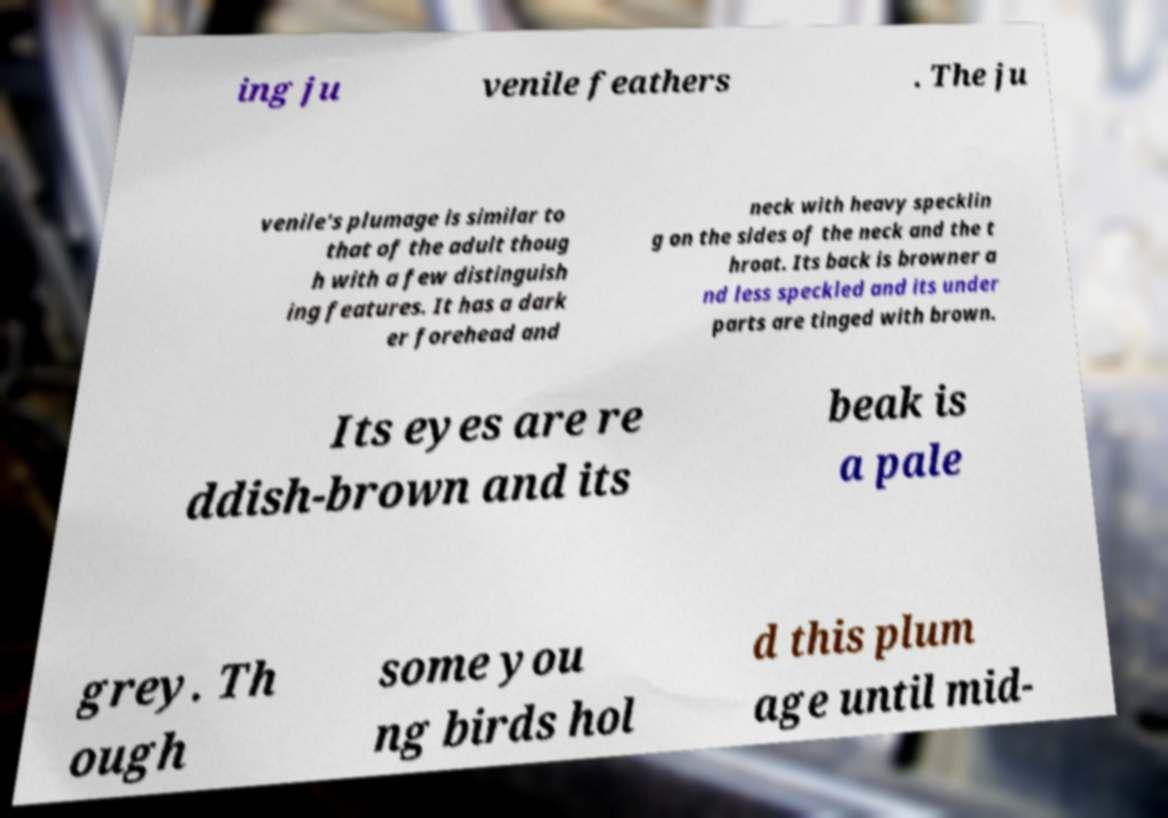Please read and relay the text visible in this image. What does it say? ing ju venile feathers . The ju venile's plumage is similar to that of the adult thoug h with a few distinguish ing features. It has a dark er forehead and neck with heavy specklin g on the sides of the neck and the t hroat. Its back is browner a nd less speckled and its under parts are tinged with brown. Its eyes are re ddish-brown and its beak is a pale grey. Th ough some you ng birds hol d this plum age until mid- 